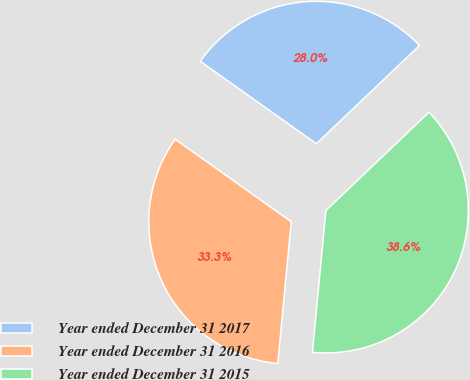Convert chart to OTSL. <chart><loc_0><loc_0><loc_500><loc_500><pie_chart><fcel>Year ended December 31 2017<fcel>Year ended December 31 2016<fcel>Year ended December 31 2015<nl><fcel>28.05%<fcel>33.33%<fcel>38.62%<nl></chart> 